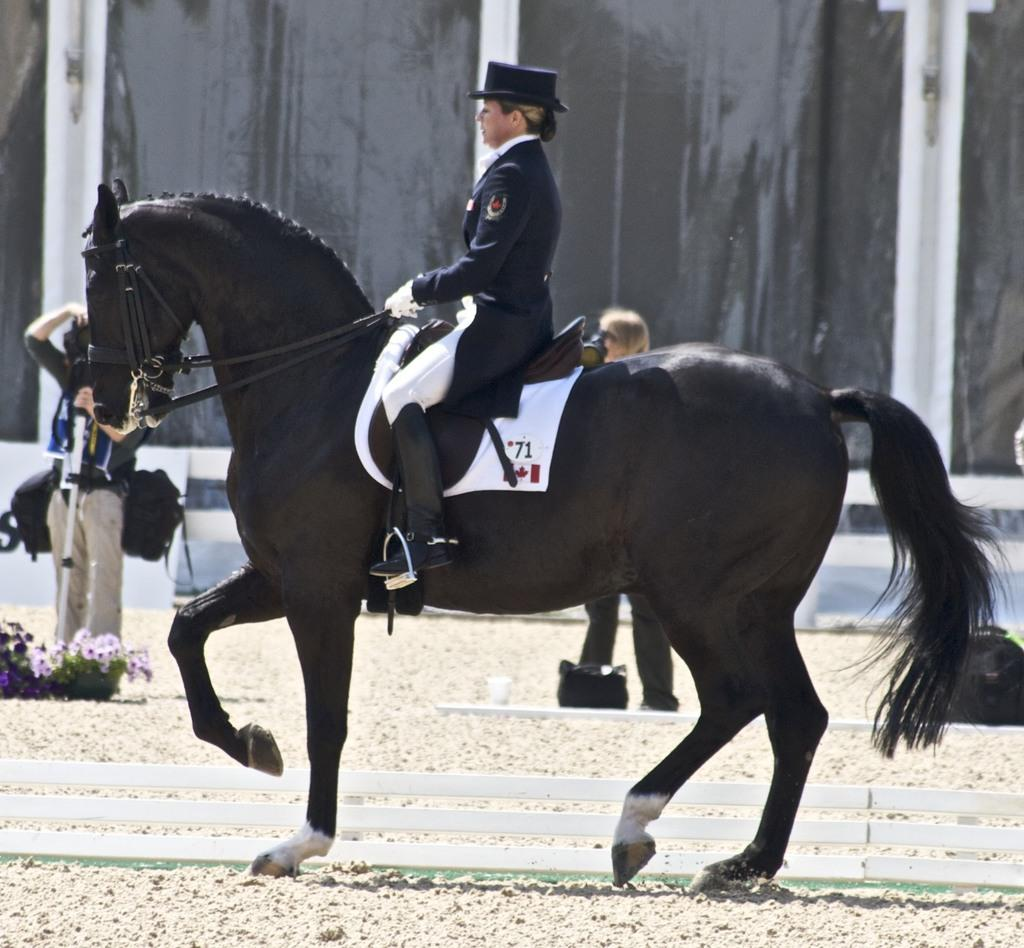What is the main subject of the image? There is a lady in the image. What is the lady doing in the image? The lady is riding a horse. What type of clothing is the lady wearing? The lady is wearing a uniform and a cap. What can be seen in the background of the image? There are people standing in the background of the image, and there is a curtain. Can you see a giraffe in the image? No, there is no giraffe present in the image. What type of feather is used to decorate the lady's uniform? There is no mention of any feathers in the description of the lady's uniform, and no feathers are visible in the image. 